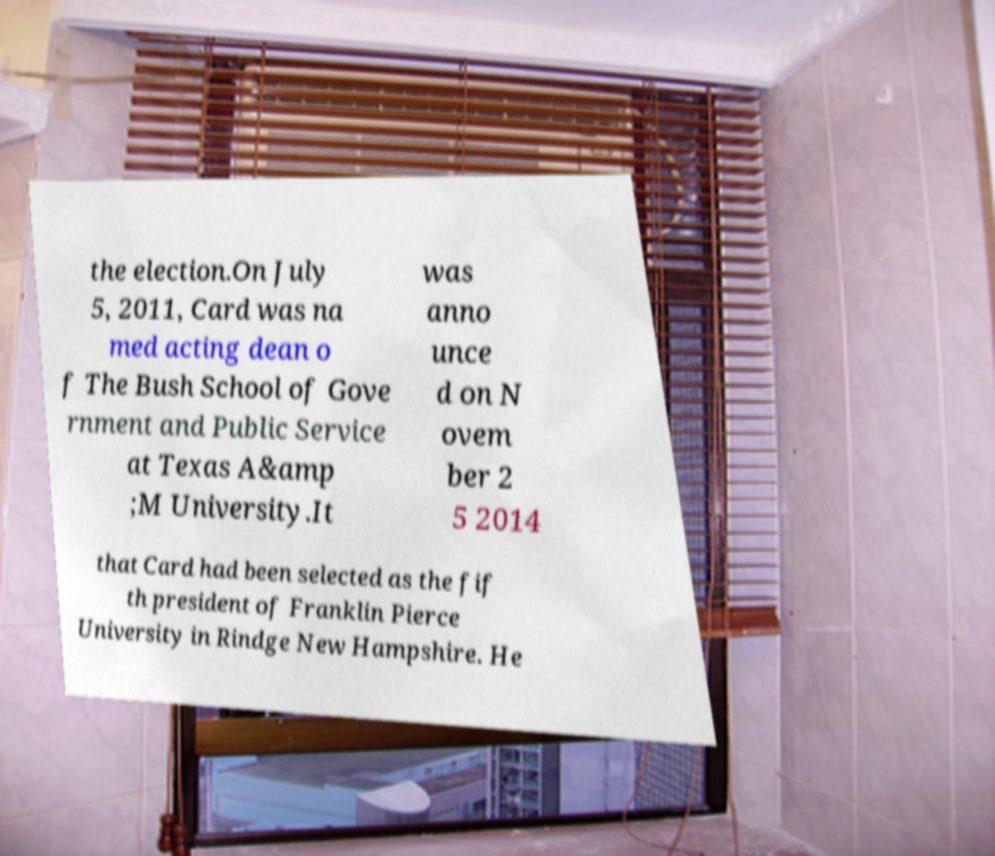There's text embedded in this image that I need extracted. Can you transcribe it verbatim? the election.On July 5, 2011, Card was na med acting dean o f The Bush School of Gove rnment and Public Service at Texas A&amp ;M University.It was anno unce d on N ovem ber 2 5 2014 that Card had been selected as the fif th president of Franklin Pierce University in Rindge New Hampshire. He 